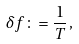Convert formula to latex. <formula><loc_0><loc_0><loc_500><loc_500>\delta f \colon = \frac { 1 } { T } \, ,</formula> 